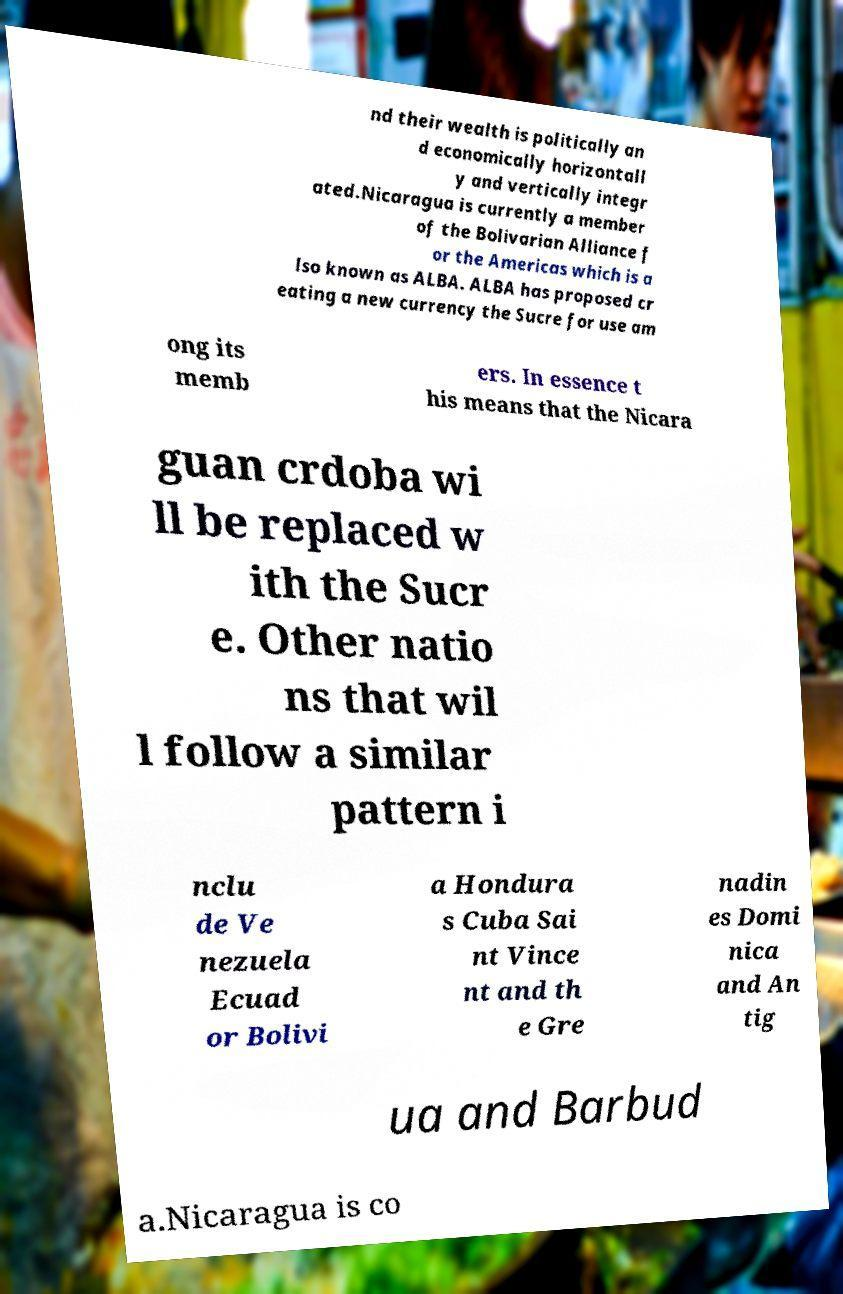Please read and relay the text visible in this image. What does it say? nd their wealth is politically an d economically horizontall y and vertically integr ated.Nicaragua is currently a member of the Bolivarian Alliance f or the Americas which is a lso known as ALBA. ALBA has proposed cr eating a new currency the Sucre for use am ong its memb ers. In essence t his means that the Nicara guan crdoba wi ll be replaced w ith the Sucr e. Other natio ns that wil l follow a similar pattern i nclu de Ve nezuela Ecuad or Bolivi a Hondura s Cuba Sai nt Vince nt and th e Gre nadin es Domi nica and An tig ua and Barbud a.Nicaragua is co 